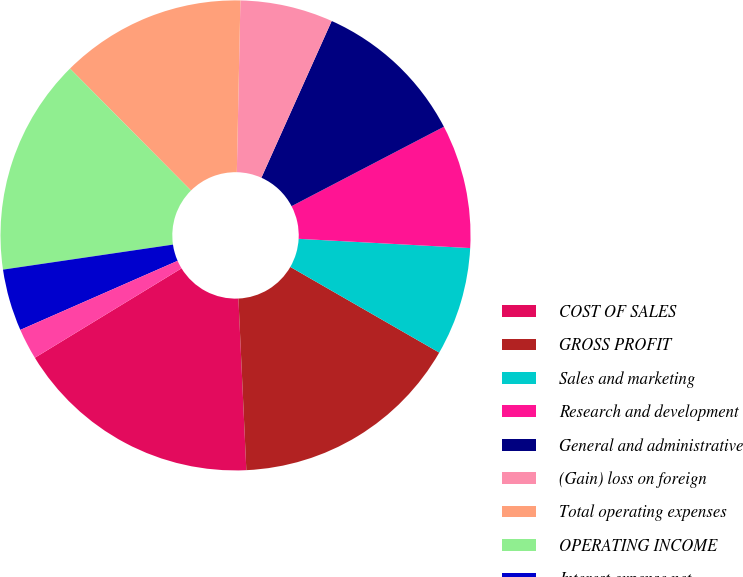Convert chart. <chart><loc_0><loc_0><loc_500><loc_500><pie_chart><fcel>COST OF SALES<fcel>GROSS PROFIT<fcel>Sales and marketing<fcel>Research and development<fcel>General and administrative<fcel>(Gain) loss on foreign<fcel>Total operating expenses<fcel>OPERATING INCOME<fcel>Interest expense net<fcel>Other income (expense) net<nl><fcel>17.02%<fcel>15.96%<fcel>7.45%<fcel>8.51%<fcel>10.64%<fcel>6.38%<fcel>12.77%<fcel>14.89%<fcel>4.26%<fcel>2.13%<nl></chart> 